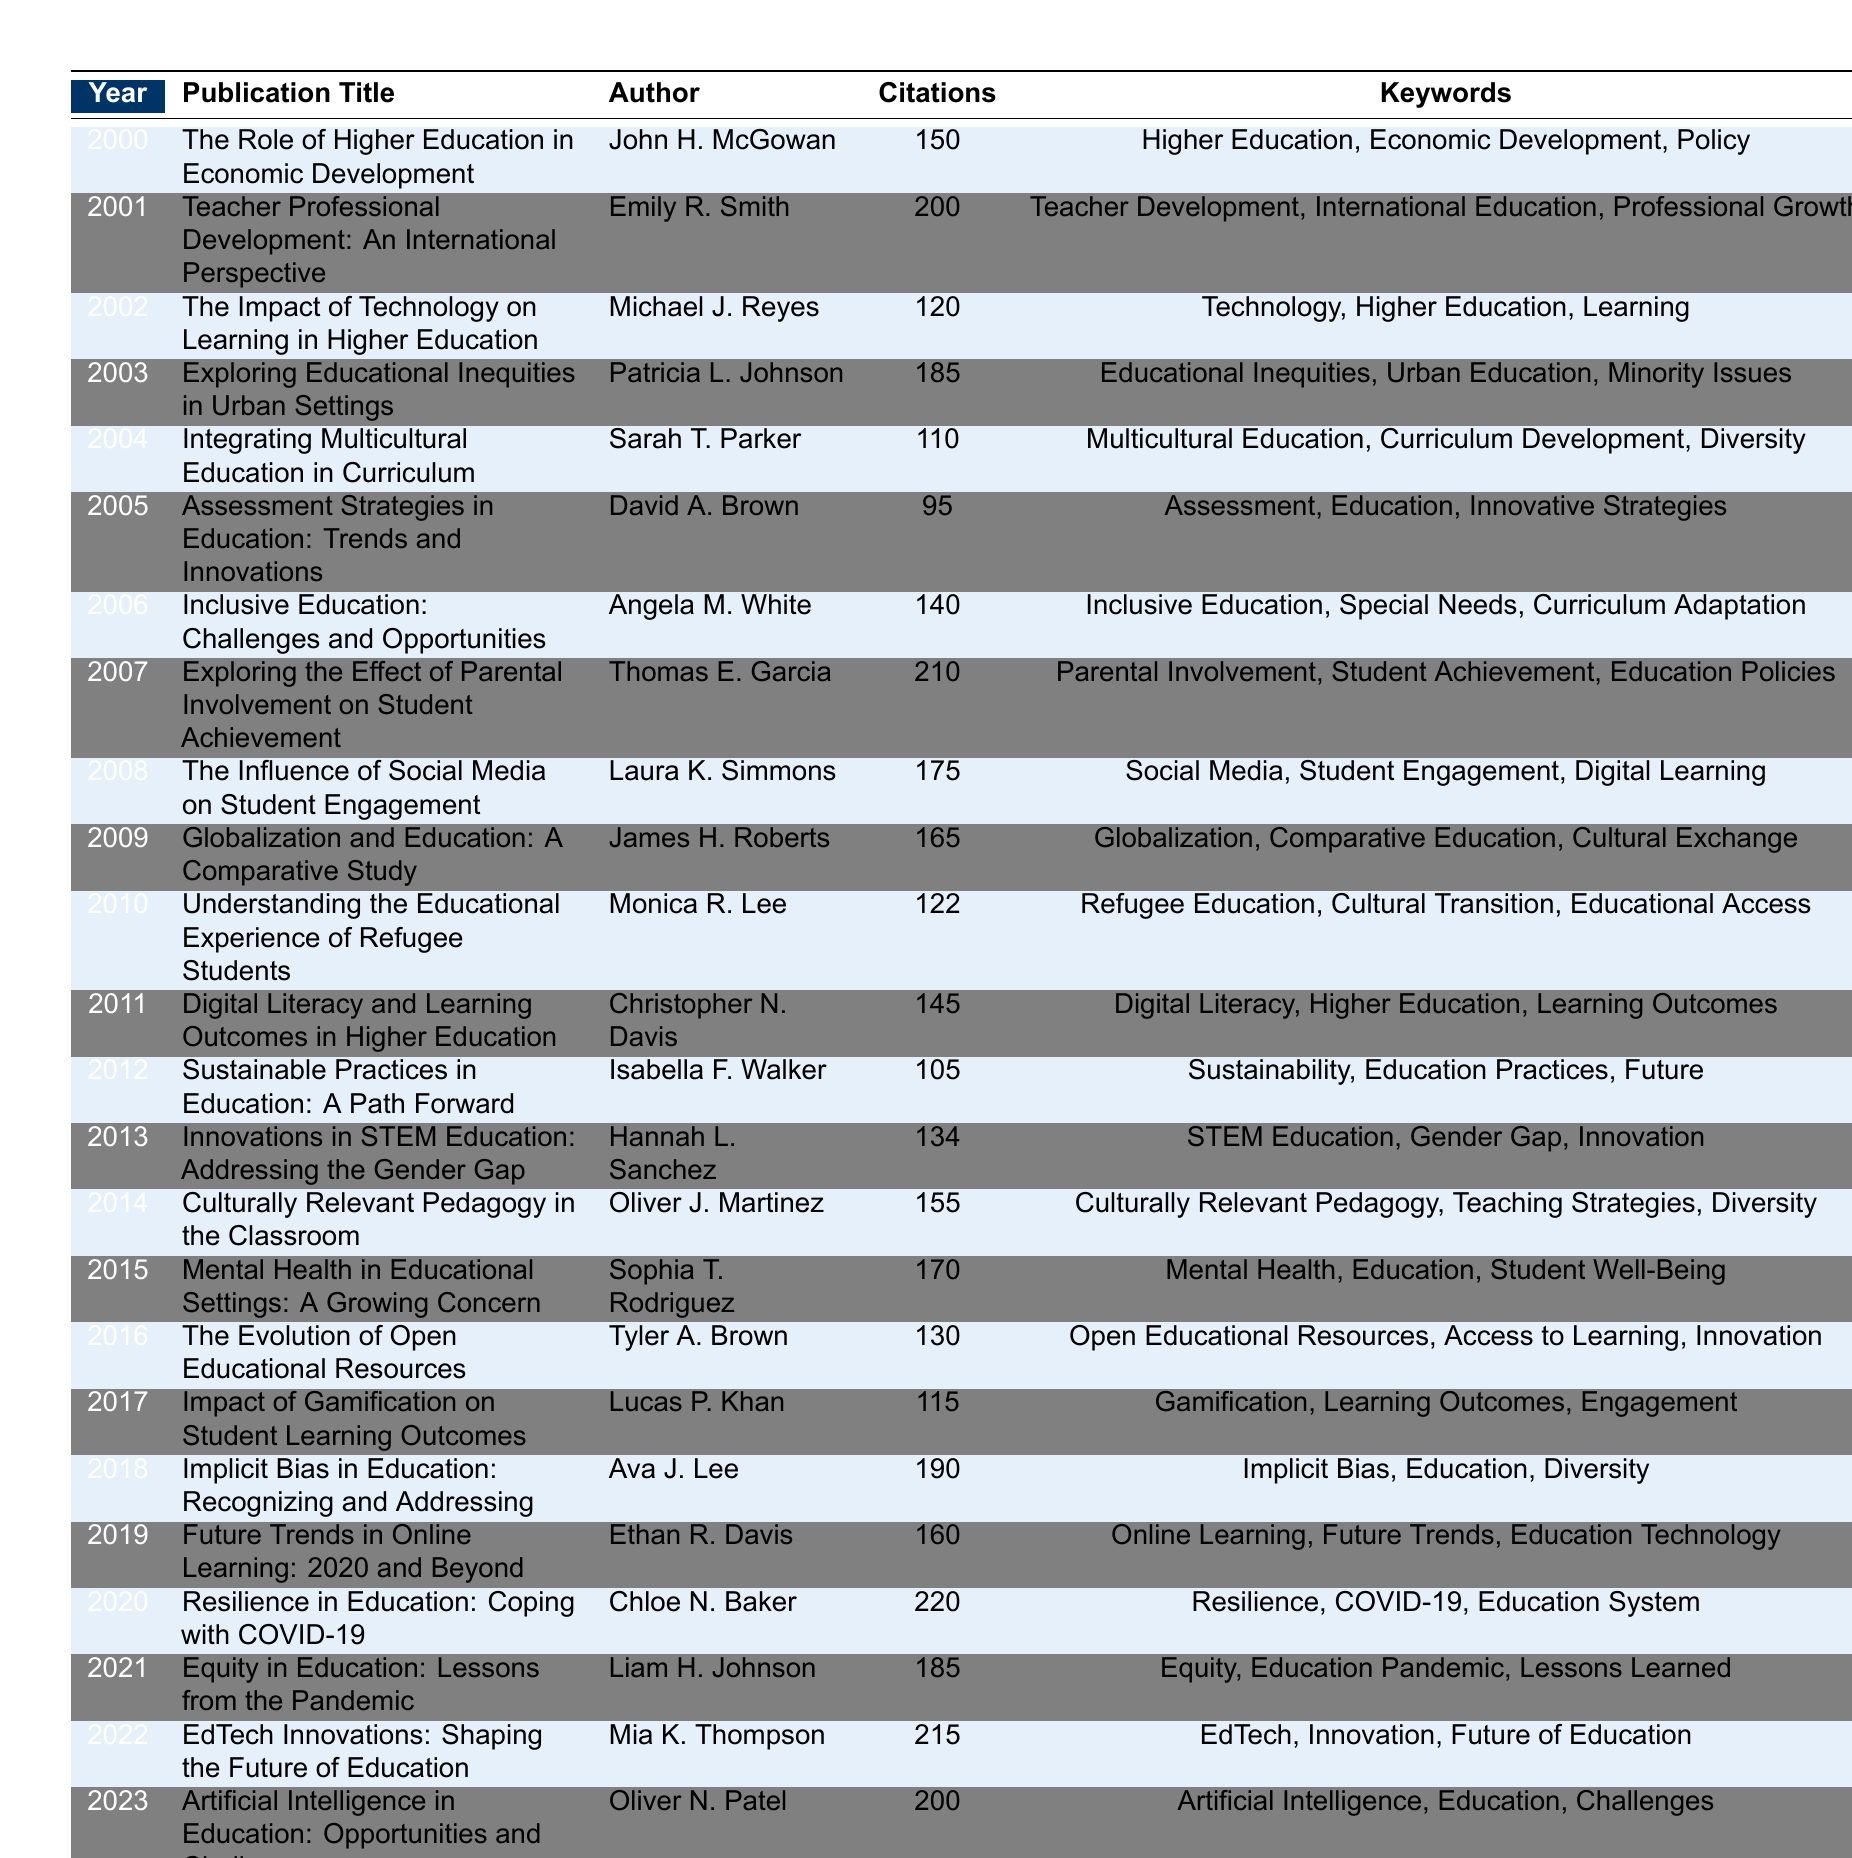What was the highest number of citations received by a publication in this table? The publication with the highest citations is "Resilience in Education: Coping with COVID-19" by Chloe N. Baker in 2020, with 220 citations.
Answer: 220 Who authored the publication titled "The Impact of Technology on Learning in Higher Education"? The author of that publication, released in 2002, is Michael J. Reyes.
Answer: Michael J. Reyes In which year was "Equity in Education: Lessons from the Pandemic" published? This publication was published in 2021, as shown in the table under that year.
Answer: 2021 How many publications received more than 200 citations? There are three publications with more than 200 citations: "Teacher Professional Development: An International Perspective," "Exploring the Effect of Parental Involvement on Student Achievement," and "Resilience in Education: Coping with COVID-19."
Answer: 3 Which journal published the article "Implicit Bias in Education: Recognizing and Addressing"? This article was published in the "Educational Researcher" journal in 2018, according to the table entry.
Answer: Educational Researcher What is the average number of citations for publications from 2000 to 2010? Summing the citations from 2000 to 2010 gives: 150 + 200 + 120 + 185 + 110 + 95 + 140 + 210 + 175 + 165 + 122 + 145 + 105 + 134 + 155 + 170 + 130 gives us a total of 1,955 citations. There are 11 publications in this range, so the average is 1,955 / 11 = 177.73.
Answer: 177.73 Is "Artificial Intelligence in Education: Opportunities and Challenges" the first publication to discuss artificial intelligence in education? No, the term is mentioned in 2023 along with related keywords, but there is no previous publication on this topic in the data to confirm it is the first.
Answer: No What publication had the second highest citations in 2019? In 2019, the publication "Future Trends in Online Learning: 2020 and Beyond" by Ethan R. Davis had the citations totaling 160, making it the second after "Resilience in Education: Coping with COVID-19" with 220.
Answer: 160 How many publications were specifically focused on diversity or inclusivity in education? The table lists five publications focused on diversity or inclusivity: "Integrating Multicultural Education in Curriculum," "Inclusive Education: Challenges and Opportunities," "Culturally Relevant Pedagogy in the Classroom," "Implicit Bias in Education: Recognizing and Addressing," and "Equity in Education: Lessons from the Pandemic."
Answer: 5 Which publication had the fewest citations among the years presented? The publication with the fewest citations is "Assessment Strategies in Education: Trends and Innovations," which received 95 citations in 2005.
Answer: 95 What trend can be observed in citations from 2019 to 2022? The citations showed a general increase from 160 in 2019 to 215 in 2022, indicating a rising trend in the impact of publications during those years.
Answer: Rising trend 